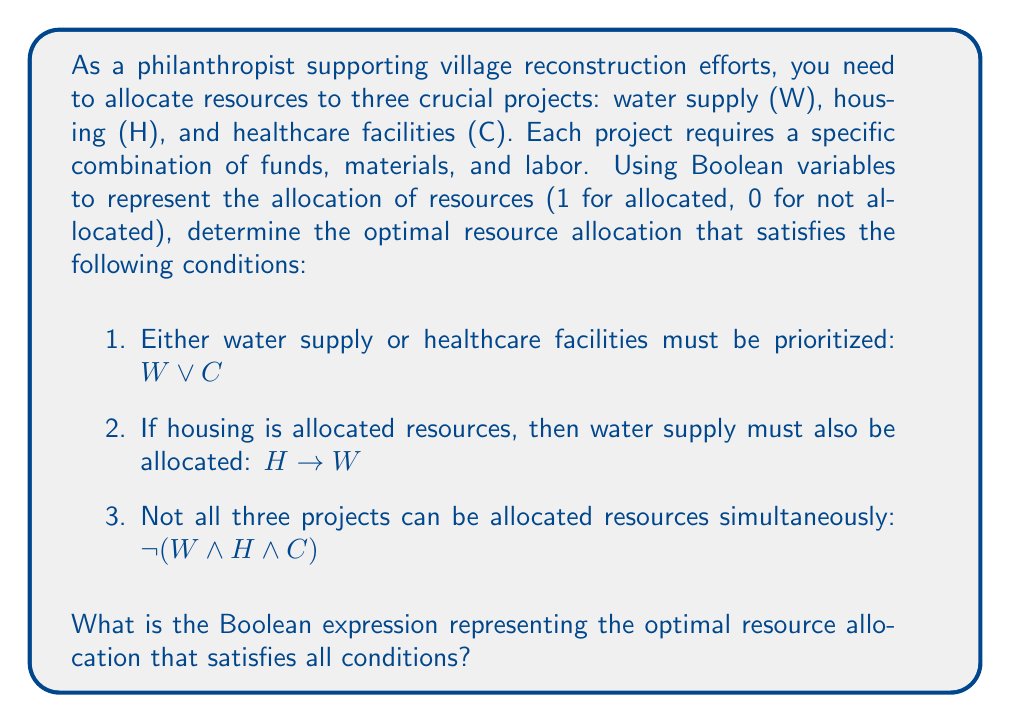What is the answer to this math problem? Let's approach this step-by-step using Boolean algebra:

1) First, let's express each condition as a Boolean expression:
   Condition 1: $W \lor C$
   Condition 2: $H \rightarrow W$ (equivalent to $\lnot H \lor W$)
   Condition 3: $\lnot(W \land H \land C)$

2) To satisfy all conditions, we need to AND these expressions:
   $(W \lor C) \land (\lnot H \lor W) \land \lnot(W \land H \land C)$

3) Let's simplify the third term $\lnot(W \land H \land C)$:
   Using De Morgan's law, this is equivalent to $\lnot W \lor \lnot H \lor \lnot C$

4) Now our expression is:
   $(W \lor C) \land (\lnot H \lor W) \land (\lnot W \lor \lnot H \lor \lnot C)$

5) We can't simplify this further without losing information, so this is our final expression representing the optimal resource allocation.

This Boolean expression ensures that:
- Either water supply or healthcare (or both) are allocated resources
- If housing is allocated resources, water supply must also be allocated
- Not all three projects are allocated resources simultaneously
Answer: $(W \lor C) \land (\lnot H \lor W) \land (\lnot W \lor \lnot H \lor \lnot C)$ 